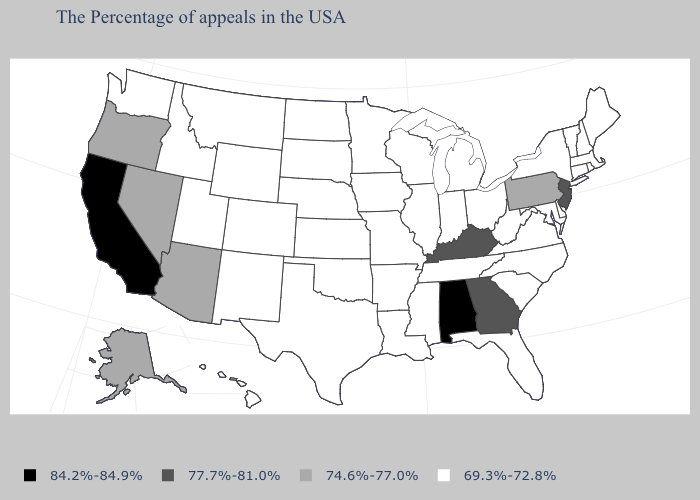What is the value of Iowa?
Quick response, please. 69.3%-72.8%. Name the states that have a value in the range 69.3%-72.8%?
Answer briefly. Maine, Massachusetts, Rhode Island, New Hampshire, Vermont, Connecticut, New York, Delaware, Maryland, Virginia, North Carolina, South Carolina, West Virginia, Ohio, Florida, Michigan, Indiana, Tennessee, Wisconsin, Illinois, Mississippi, Louisiana, Missouri, Arkansas, Minnesota, Iowa, Kansas, Nebraska, Oklahoma, Texas, South Dakota, North Dakota, Wyoming, Colorado, New Mexico, Utah, Montana, Idaho, Washington, Hawaii. How many symbols are there in the legend?
Quick response, please. 4. How many symbols are there in the legend?
Answer briefly. 4. Does North Dakota have a higher value than Vermont?
Write a very short answer. No. Which states have the lowest value in the USA?
Give a very brief answer. Maine, Massachusetts, Rhode Island, New Hampshire, Vermont, Connecticut, New York, Delaware, Maryland, Virginia, North Carolina, South Carolina, West Virginia, Ohio, Florida, Michigan, Indiana, Tennessee, Wisconsin, Illinois, Mississippi, Louisiana, Missouri, Arkansas, Minnesota, Iowa, Kansas, Nebraska, Oklahoma, Texas, South Dakota, North Dakota, Wyoming, Colorado, New Mexico, Utah, Montana, Idaho, Washington, Hawaii. Name the states that have a value in the range 77.7%-81.0%?
Be succinct. New Jersey, Georgia, Kentucky. Does Georgia have a lower value than Alabama?
Short answer required. Yes. Name the states that have a value in the range 69.3%-72.8%?
Write a very short answer. Maine, Massachusetts, Rhode Island, New Hampshire, Vermont, Connecticut, New York, Delaware, Maryland, Virginia, North Carolina, South Carolina, West Virginia, Ohio, Florida, Michigan, Indiana, Tennessee, Wisconsin, Illinois, Mississippi, Louisiana, Missouri, Arkansas, Minnesota, Iowa, Kansas, Nebraska, Oklahoma, Texas, South Dakota, North Dakota, Wyoming, Colorado, New Mexico, Utah, Montana, Idaho, Washington, Hawaii. Does Arkansas have a lower value than California?
Quick response, please. Yes. Does the map have missing data?
Keep it brief. No. Does Wisconsin have a lower value than Texas?
Be succinct. No. Name the states that have a value in the range 74.6%-77.0%?
Give a very brief answer. Pennsylvania, Arizona, Nevada, Oregon, Alaska. 